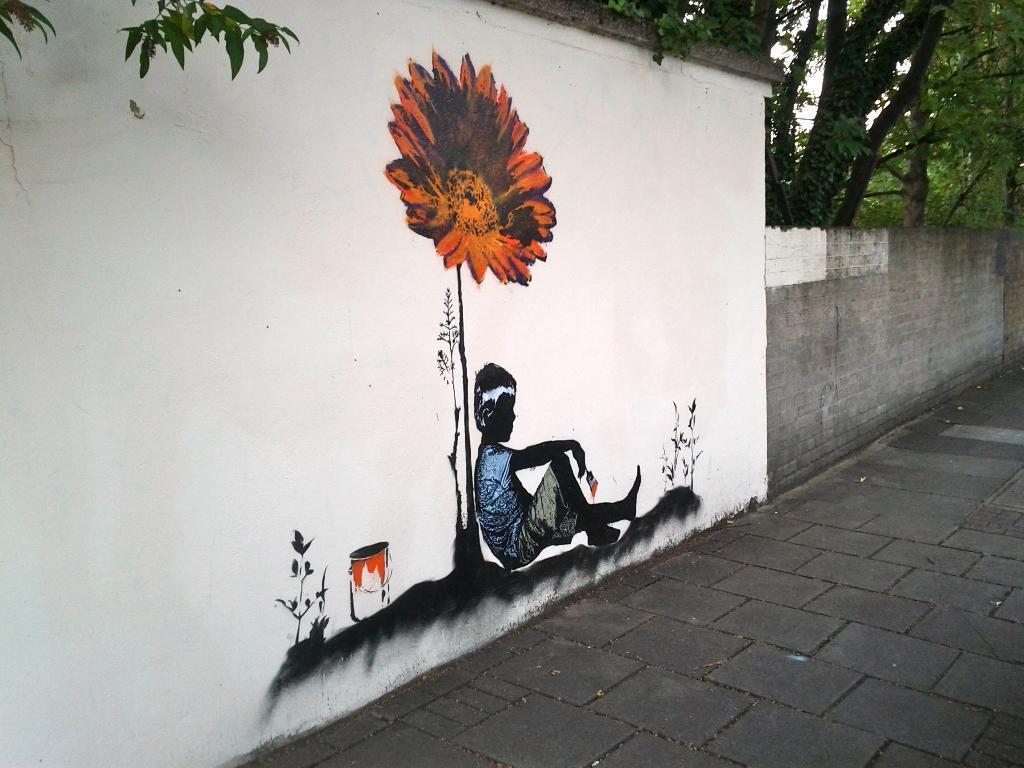How would you summarize this image in a sentence or two? In the image we can see a wall, on the wall there is a painting of a flower and a child sitting, wearing clothes and holding a brush in hand and this is a plant. This is a tree and footpath. 